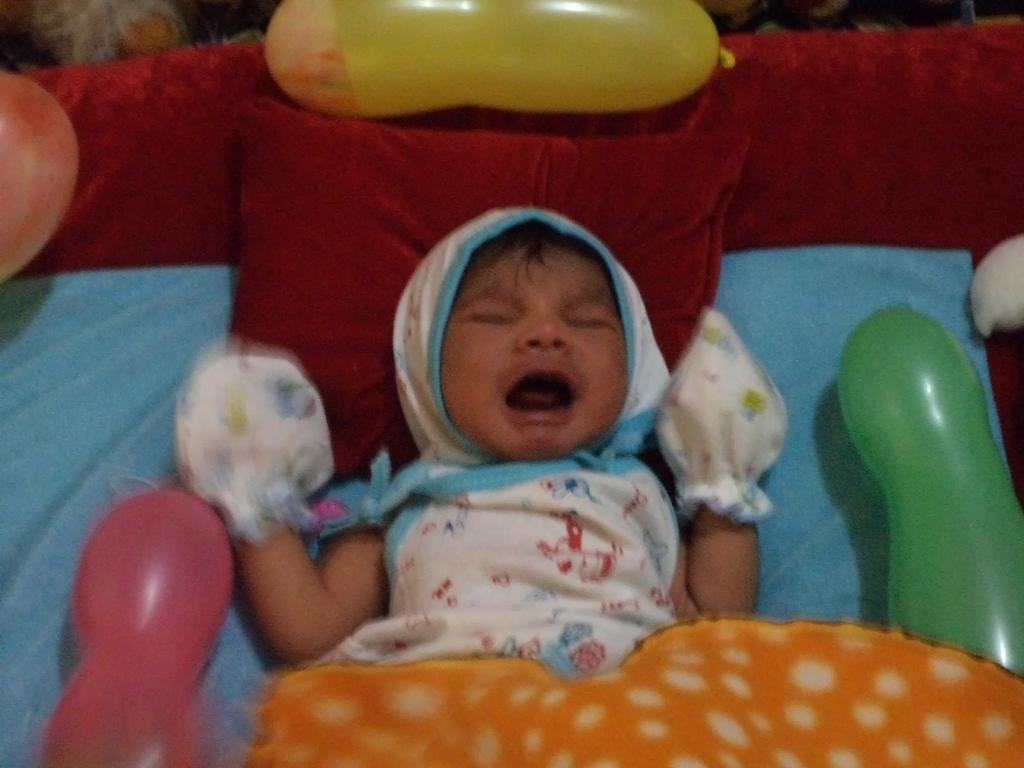What piece of furniture is present in the image? There is a bed in the image. What can be seen on the bed? There are red cushions, balloons, and an orange color cloth on the bed. What is the baby in the image wearing? The baby is wearing a white and blue color dress. What type of stone can be seen in the image? There is no stone present in the image. Can you describe the clouds in the image? There are no clouds visible in the image. 